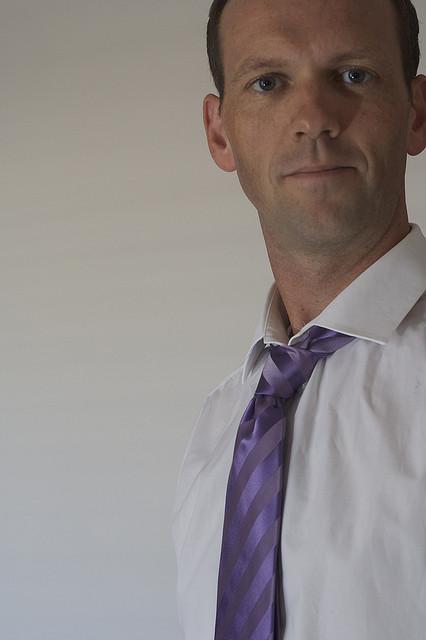Is the shirt buttoned all the way to the top?
Be succinct. Yes. Is there a backlight on?
Concise answer only. No. What is the man on the right doing?
Write a very short answer. Posing. Does he look like a Dr?
Write a very short answer. Yes. Who is the man in the image?
Quick response, please. Businessman. Does the man have something in his left ear?
Write a very short answer. No. Does the man have a bowtie on?
Be succinct. No. What is he wearing around his neck?
Quick response, please. Tie. What is the pattern on the tie known as?
Write a very short answer. Stripes. Is the man wearing glasses?
Answer briefly. No. Is the person dreaming?
Write a very short answer. No. Is this person nude?
Answer briefly. No. Does the man have facial hair?
Keep it brief. No. What color is this man's shirt?
Keep it brief. White. Are there circles on the man's tie?
Keep it brief. No. Is there a shadow on the neck?
Quick response, please. No. Is the man happy?
Give a very brief answer. No. Is this man wearing glasses?
Answer briefly. No. What pattern is on the tie?
Be succinct. Striped. Does he have facial hair?
Quick response, please. No. What color is this necktie?
Concise answer only. Purple. Which retail chain has a logo similar to this man's tie?
Quick response, please. None. Is the old or young?
Concise answer only. Young. Does he need to shave?
Keep it brief. No. Is that a normal tie?
Write a very short answer. Yes. Has this man recently had a haircut?
Give a very brief answer. Yes. Is there text in this photo?
Quick response, please. No. 